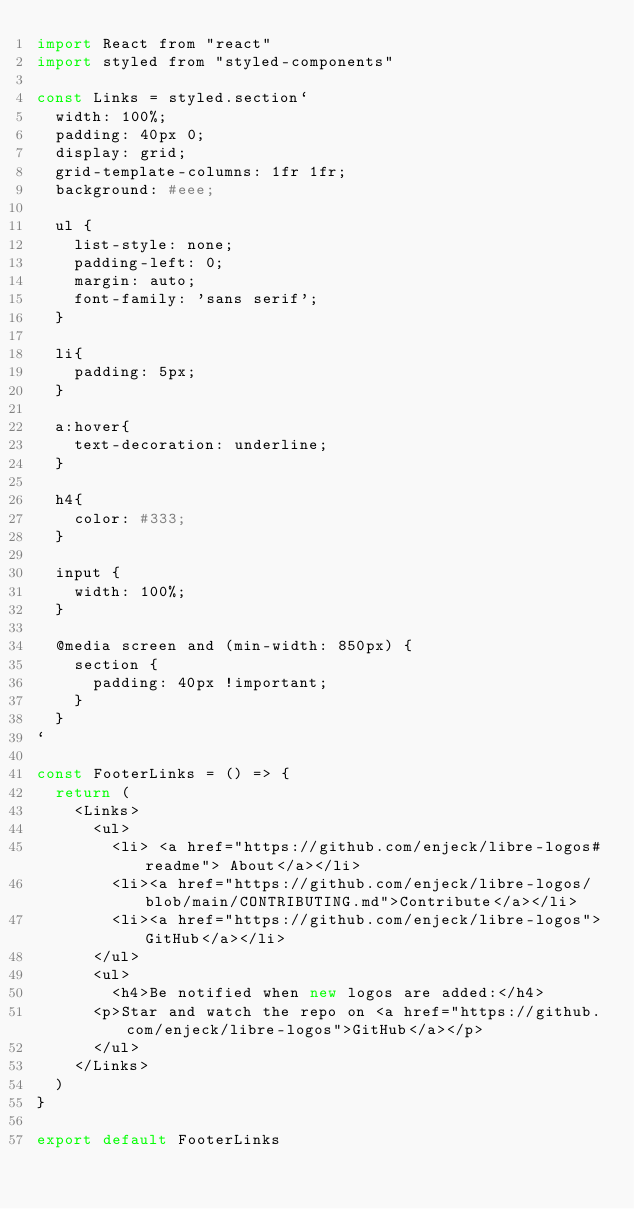<code> <loc_0><loc_0><loc_500><loc_500><_JavaScript_>import React from "react"
import styled from "styled-components"

const Links = styled.section`
  width: 100%;
  padding: 40px 0;
  display: grid;
  grid-template-columns: 1fr 1fr;
  background: #eee;

  ul {
    list-style: none;
    padding-left: 0;
    margin: auto;
    font-family: 'sans serif';
  }

  li{
    padding: 5px;
  }

  a:hover{
    text-decoration: underline;
  }

  h4{
    color: #333;
  }

  input {
    width: 100%;
  }

  @media screen and (min-width: 850px) {
    section {
      padding: 40px !important;
    }
  }
`

const FooterLinks = () => {
  return (
    <Links>
      <ul>
        <li> <a href="https://github.com/enjeck/libre-logos#readme"> About</a></li>
        <li><a href="https://github.com/enjeck/libre-logos/blob/main/CONTRIBUTING.md">Contribute</a></li>
        <li><a href="https://github.com/enjeck/libre-logos">GitHub</a></li>
      </ul>
      <ul>
        <h4>Be notified when new logos are added:</h4>
      <p>Star and watch the repo on <a href="https://github.com/enjeck/libre-logos">GitHub</a></p>
      </ul>
    </Links>
  )
}

export default FooterLinks
</code> 